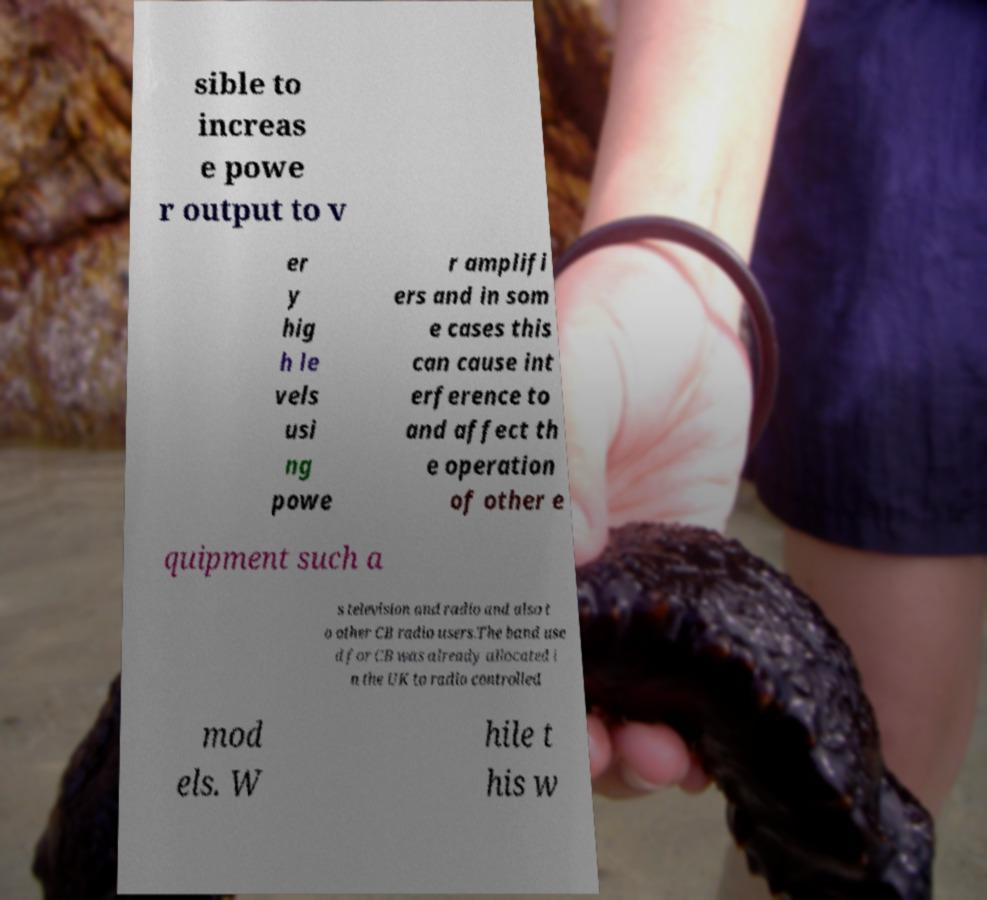What messages or text are displayed in this image? I need them in a readable, typed format. sible to increas e powe r output to v er y hig h le vels usi ng powe r amplifi ers and in som e cases this can cause int erference to and affect th e operation of other e quipment such a s television and radio and also t o other CB radio users.The band use d for CB was already allocated i n the UK to radio controlled mod els. W hile t his w 